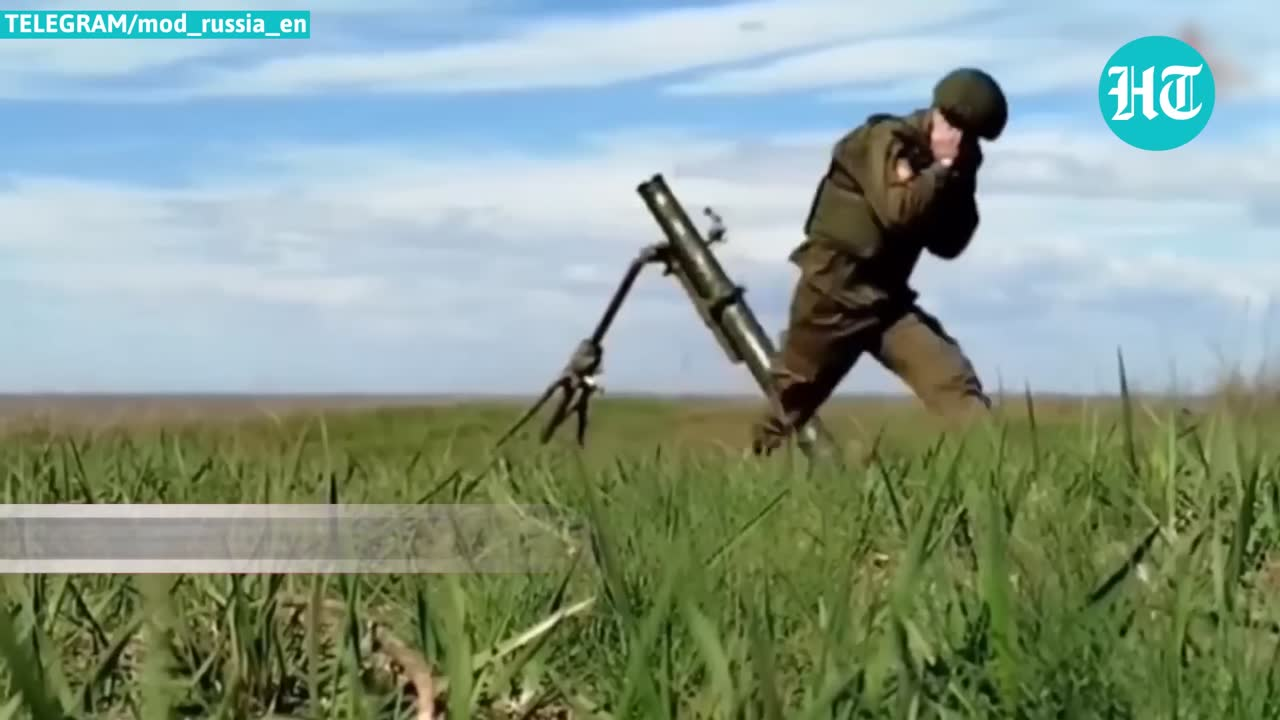describe the img The image depicts a person wearing olive green military fatigues and carrying what appears to be a mortar or artillery weapon system through a grassy field or meadow under a cloudy sky. The individual is moving while holding and positioning the weapon, suggesting they may be involved in military training or operations involving this type of heavy weapon system. However, I cannot identify any specific individuals shown due to the need to protect privacy. 